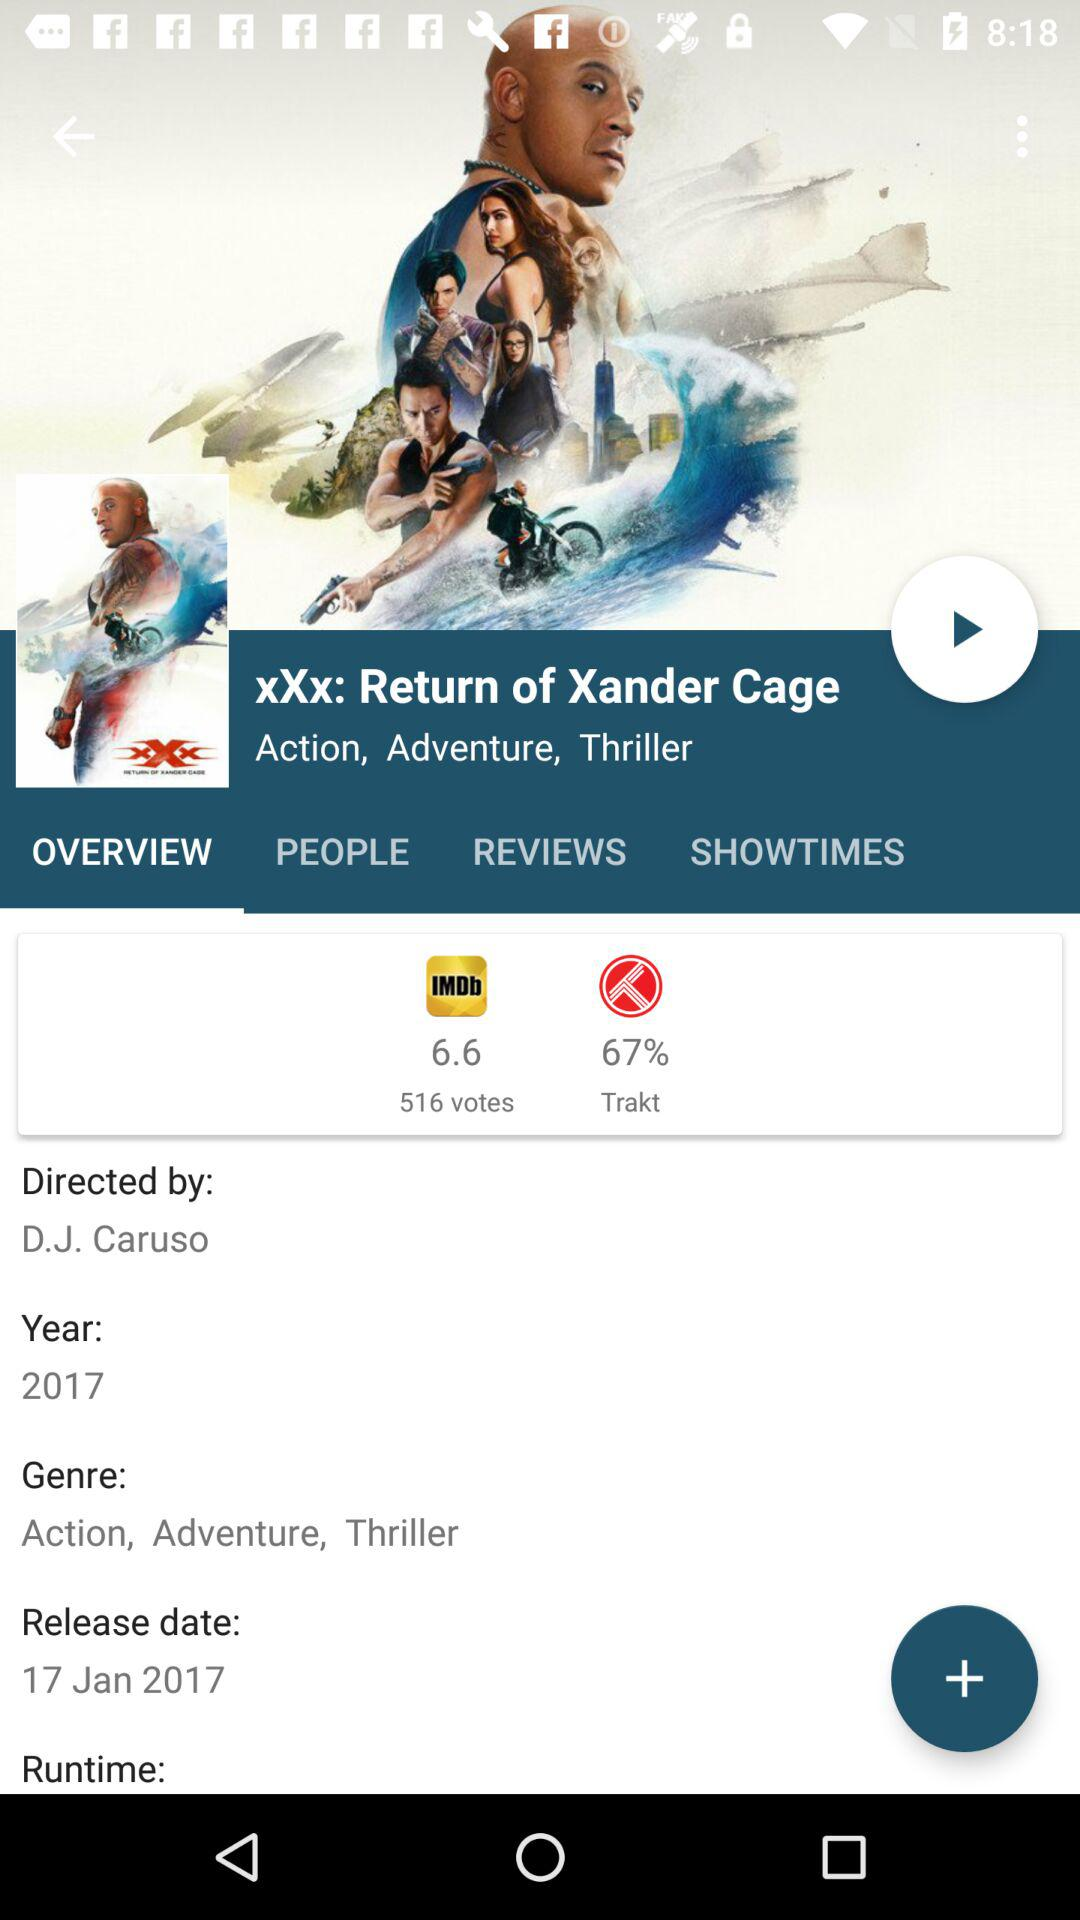What is the title of the movie? The title of the movie is "xXx: Return of Xander Cage". 